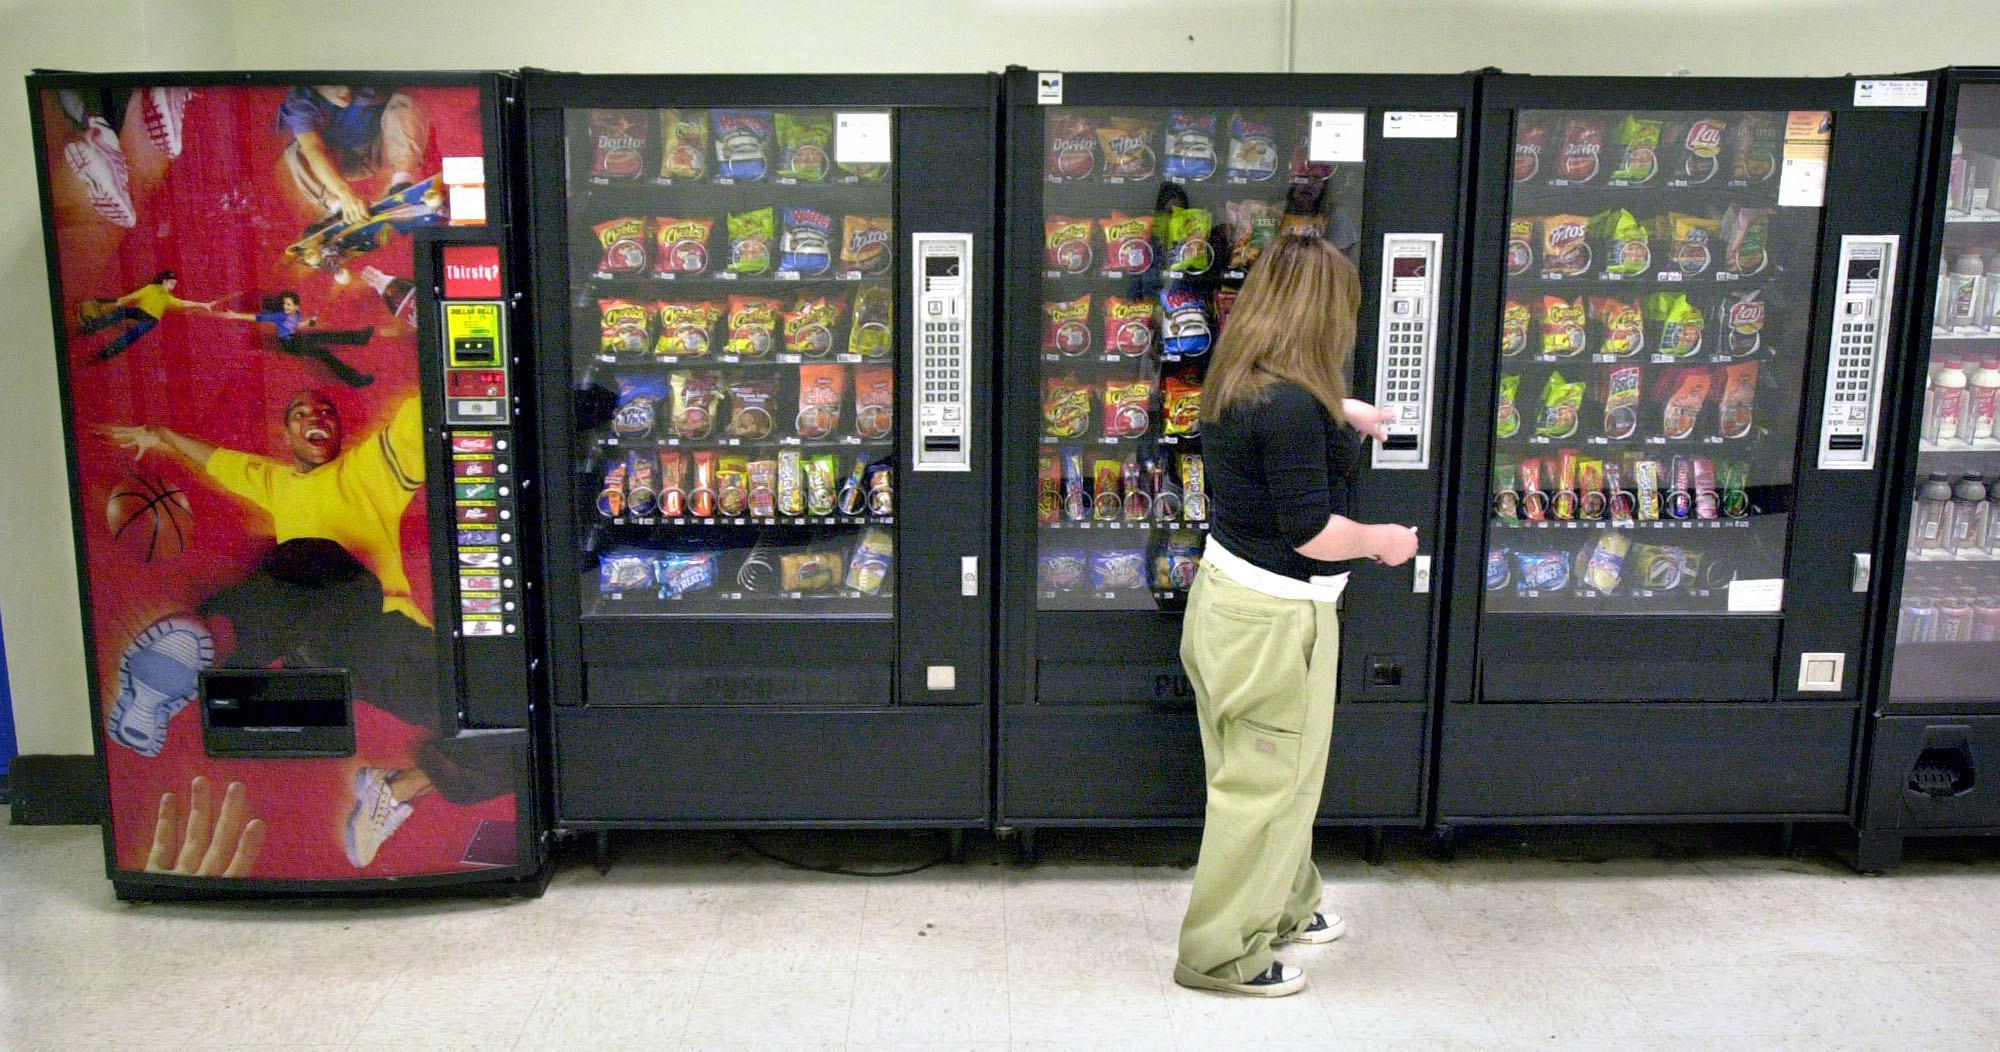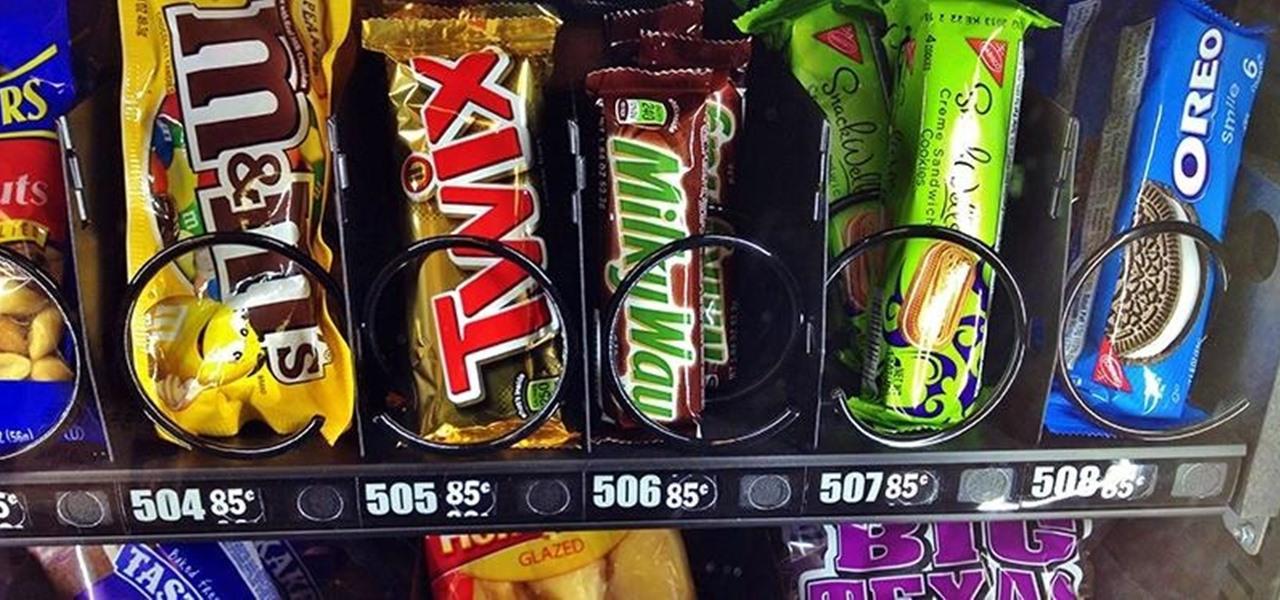The first image is the image on the left, the second image is the image on the right. Analyze the images presented: Is the assertion "At least one image shows only beverage vending options." valid? Answer yes or no. No. 